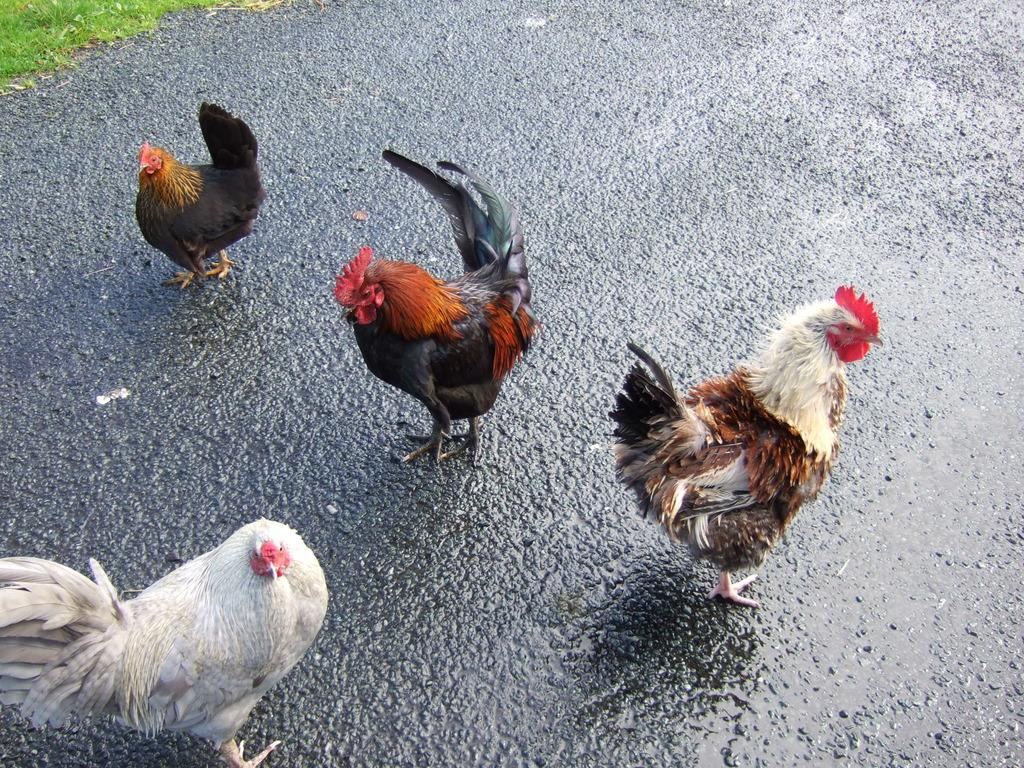What type of animals can be seen in the image? There are roosters and hens in the image. Where are the roosters and hens located? Both roosters and hens are on the road. What type of scarf is the rooster wearing in the image? There is no scarf present in the image, as roosters do not wear clothing. 